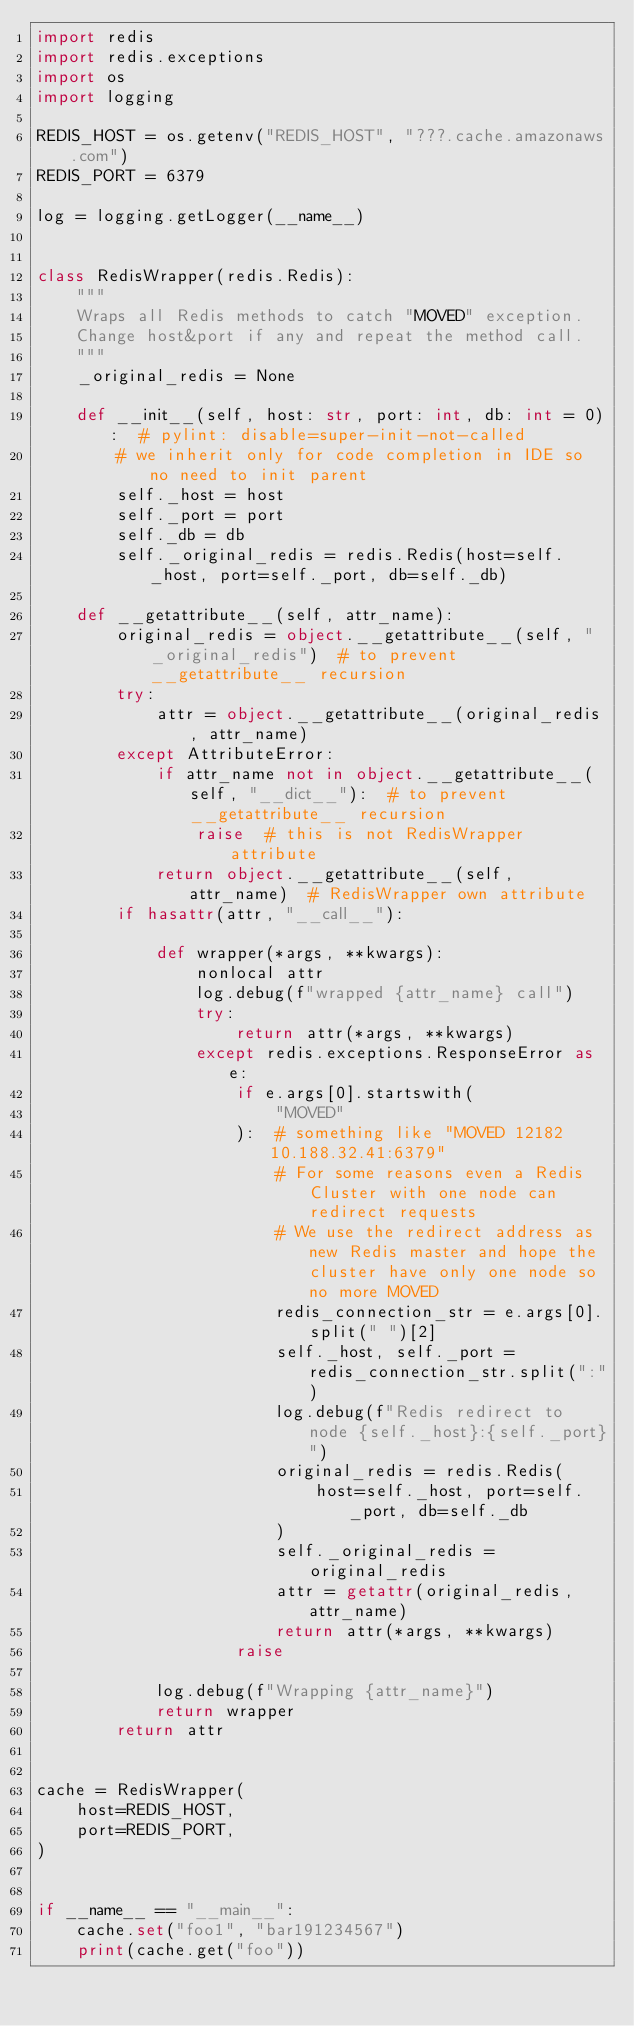Convert code to text. <code><loc_0><loc_0><loc_500><loc_500><_Python_>import redis
import redis.exceptions
import os
import logging

REDIS_HOST = os.getenv("REDIS_HOST", "???.cache.amazonaws.com")
REDIS_PORT = 6379

log = logging.getLogger(__name__)


class RedisWrapper(redis.Redis):
    """
    Wraps all Redis methods to catch "MOVED" exception.
    Change host&port if any and repeat the method call.
    """
    _original_redis = None

    def __init__(self, host: str, port: int, db: int = 0):  # pylint: disable=super-init-not-called
        # we inherit only for code completion in IDE so no need to init parent
        self._host = host
        self._port = port
        self._db = db
        self._original_redis = redis.Redis(host=self._host, port=self._port, db=self._db)

    def __getattribute__(self, attr_name):
        original_redis = object.__getattribute__(self, "_original_redis")  # to prevent __getattribute__ recursion
        try:
            attr = object.__getattribute__(original_redis, attr_name)
        except AttributeError:
            if attr_name not in object.__getattribute__(self, "__dict__"):  # to prevent __getattribute__ recursion
                raise  # this is not RedisWrapper attribute
            return object.__getattribute__(self, attr_name)  # RedisWrapper own attribute
        if hasattr(attr, "__call__"):

            def wrapper(*args, **kwargs):
                nonlocal attr
                log.debug(f"wrapped {attr_name} call")
                try:
                    return attr(*args, **kwargs)
                except redis.exceptions.ResponseError as e:
                    if e.args[0].startswith(
                        "MOVED"
                    ):  # something like "MOVED 12182 10.188.32.41:6379"
                        # For some reasons even a Redis Cluster with one node can redirect requests
                        # We use the redirect address as new Redis master and hope the cluster have only one node so no more MOVED
                        redis_connection_str = e.args[0].split(" ")[2]
                        self._host, self._port = redis_connection_str.split(":")
                        log.debug(f"Redis redirect to node {self._host}:{self._port}")
                        original_redis = redis.Redis(
                            host=self._host, port=self._port, db=self._db
                        )
                        self._original_redis = original_redis
                        attr = getattr(original_redis, attr_name)
                        return attr(*args, **kwargs)
                    raise

            log.debug(f"Wrapping {attr_name}")
            return wrapper
        return attr


cache = RedisWrapper(
    host=REDIS_HOST,
    port=REDIS_PORT,
)


if __name__ == "__main__":
    cache.set("foo1", "bar191234567")
    print(cache.get("foo"))
</code> 